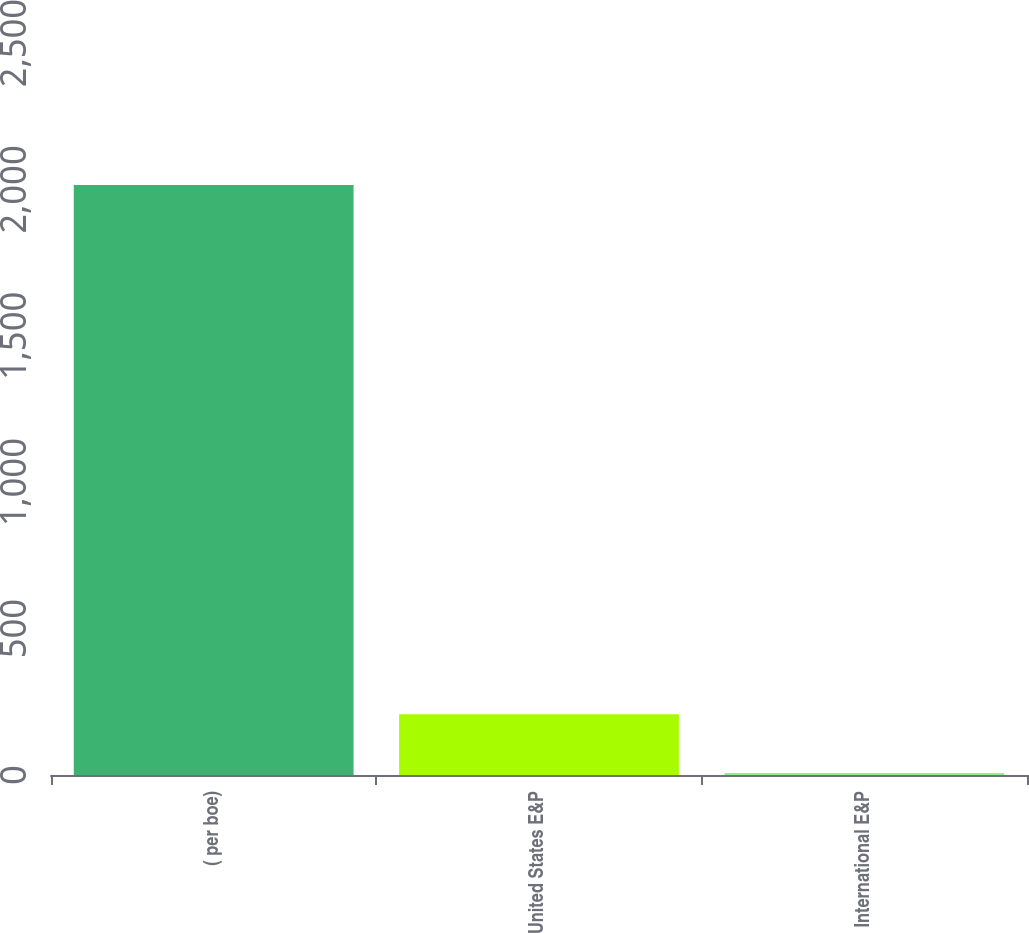Convert chart. <chart><loc_0><loc_0><loc_500><loc_500><bar_chart><fcel>( per boe)<fcel>United States E&P<fcel>International E&P<nl><fcel>2015<fcel>207.75<fcel>6.95<nl></chart> 